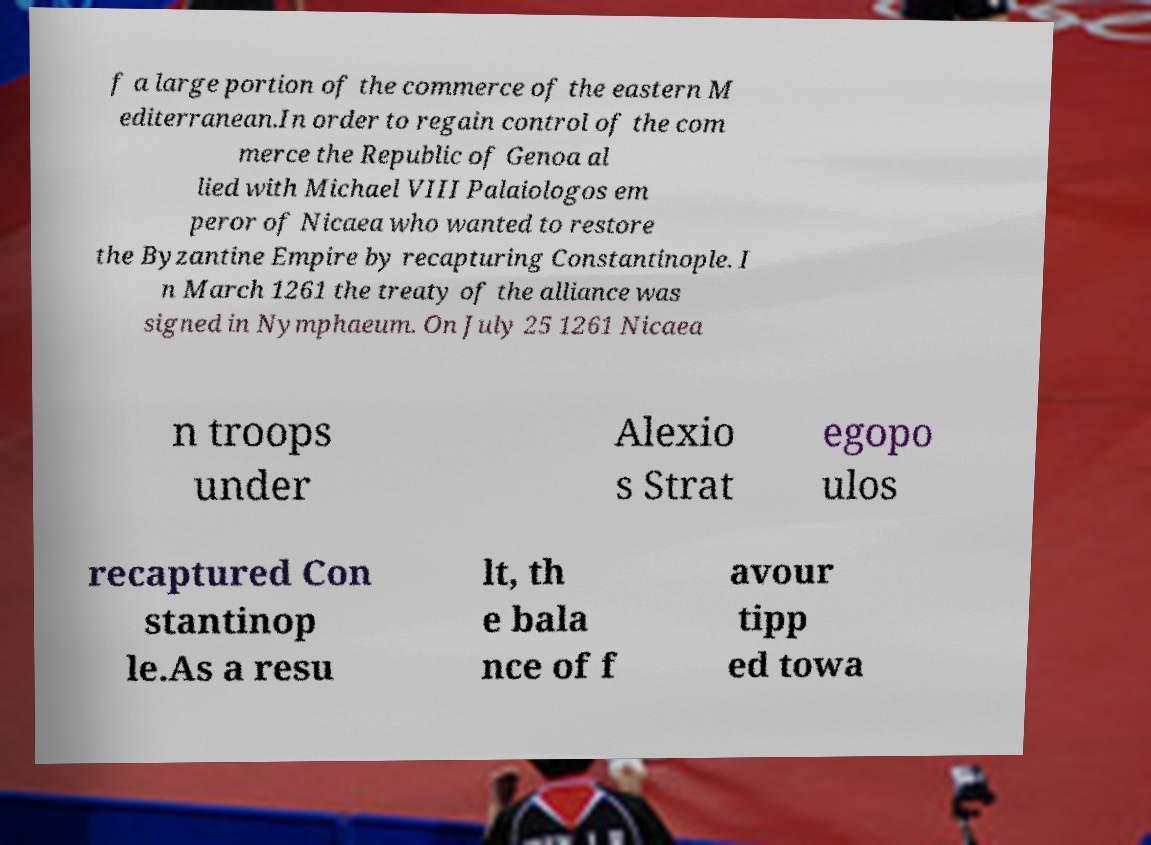There's text embedded in this image that I need extracted. Can you transcribe it verbatim? f a large portion of the commerce of the eastern M editerranean.In order to regain control of the com merce the Republic of Genoa al lied with Michael VIII Palaiologos em peror of Nicaea who wanted to restore the Byzantine Empire by recapturing Constantinople. I n March 1261 the treaty of the alliance was signed in Nymphaeum. On July 25 1261 Nicaea n troops under Alexio s Strat egopo ulos recaptured Con stantinop le.As a resu lt, th e bala nce of f avour tipp ed towa 